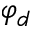<formula> <loc_0><loc_0><loc_500><loc_500>\varphi _ { d }</formula> 